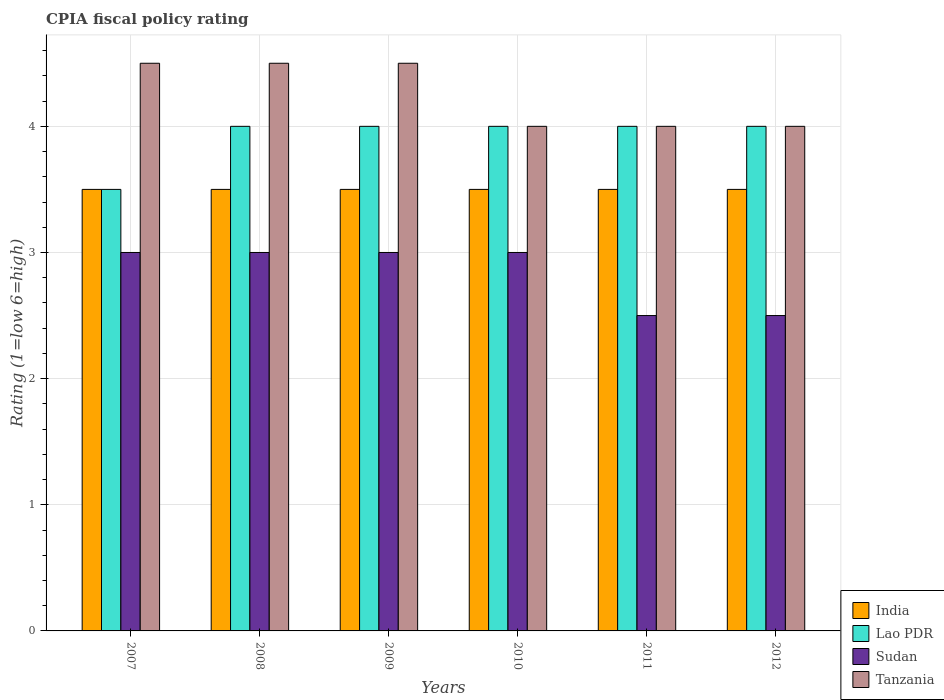Are the number of bars per tick equal to the number of legend labels?
Offer a very short reply. Yes. How many bars are there on the 3rd tick from the left?
Offer a very short reply. 4. How many bars are there on the 5th tick from the right?
Offer a very short reply. 4. In how many cases, is the number of bars for a given year not equal to the number of legend labels?
Offer a terse response. 0. What is the CPIA rating in Sudan in 2009?
Give a very brief answer. 3. Across all years, what is the maximum CPIA rating in India?
Make the answer very short. 3.5. What is the difference between the CPIA rating in India in 2007 and the CPIA rating in Tanzania in 2010?
Provide a short and direct response. -0.5. What is the average CPIA rating in India per year?
Give a very brief answer. 3.5. In the year 2012, what is the difference between the CPIA rating in Sudan and CPIA rating in Tanzania?
Offer a very short reply. -1.5. In how many years, is the CPIA rating in India greater than 3.4?
Make the answer very short. 6. What is the ratio of the CPIA rating in Sudan in 2009 to that in 2010?
Provide a succinct answer. 1. Is the CPIA rating in Sudan in 2007 less than that in 2011?
Give a very brief answer. No. Is the difference between the CPIA rating in Sudan in 2007 and 2011 greater than the difference between the CPIA rating in Tanzania in 2007 and 2011?
Give a very brief answer. No. Is it the case that in every year, the sum of the CPIA rating in Sudan and CPIA rating in Lao PDR is greater than the sum of CPIA rating in Tanzania and CPIA rating in India?
Ensure brevity in your answer.  No. What does the 3rd bar from the left in 2012 represents?
Your answer should be very brief. Sudan. How many years are there in the graph?
Provide a succinct answer. 6. Are the values on the major ticks of Y-axis written in scientific E-notation?
Provide a succinct answer. No. Does the graph contain any zero values?
Ensure brevity in your answer.  No. Where does the legend appear in the graph?
Provide a short and direct response. Bottom right. How many legend labels are there?
Provide a short and direct response. 4. How are the legend labels stacked?
Ensure brevity in your answer.  Vertical. What is the title of the graph?
Give a very brief answer. CPIA fiscal policy rating. Does "Macao" appear as one of the legend labels in the graph?
Provide a succinct answer. No. What is the Rating (1=low 6=high) of India in 2007?
Offer a very short reply. 3.5. What is the Rating (1=low 6=high) in Lao PDR in 2008?
Give a very brief answer. 4. What is the Rating (1=low 6=high) of Tanzania in 2008?
Provide a succinct answer. 4.5. What is the Rating (1=low 6=high) of India in 2009?
Provide a succinct answer. 3.5. What is the Rating (1=low 6=high) in Lao PDR in 2009?
Offer a very short reply. 4. What is the Rating (1=low 6=high) in India in 2010?
Give a very brief answer. 3.5. What is the Rating (1=low 6=high) of Lao PDR in 2010?
Your answer should be compact. 4. What is the Rating (1=low 6=high) of Sudan in 2010?
Offer a very short reply. 3. What is the Rating (1=low 6=high) in Tanzania in 2010?
Your answer should be compact. 4. What is the Rating (1=low 6=high) in Lao PDR in 2011?
Provide a succinct answer. 4. What is the Rating (1=low 6=high) of Lao PDR in 2012?
Offer a very short reply. 4. What is the Rating (1=low 6=high) of Sudan in 2012?
Provide a short and direct response. 2.5. Across all years, what is the maximum Rating (1=low 6=high) of Lao PDR?
Provide a succinct answer. 4. Across all years, what is the maximum Rating (1=low 6=high) in Sudan?
Make the answer very short. 3. Across all years, what is the minimum Rating (1=low 6=high) in Lao PDR?
Provide a short and direct response. 3.5. Across all years, what is the minimum Rating (1=low 6=high) of Sudan?
Give a very brief answer. 2.5. What is the total Rating (1=low 6=high) of India in the graph?
Offer a very short reply. 21. What is the total Rating (1=low 6=high) in Sudan in the graph?
Keep it short and to the point. 17. What is the difference between the Rating (1=low 6=high) in Lao PDR in 2007 and that in 2008?
Provide a succinct answer. -0.5. What is the difference between the Rating (1=low 6=high) in Tanzania in 2007 and that in 2008?
Ensure brevity in your answer.  0. What is the difference between the Rating (1=low 6=high) in Lao PDR in 2007 and that in 2011?
Offer a terse response. -0.5. What is the difference between the Rating (1=low 6=high) of Sudan in 2007 and that in 2011?
Provide a succinct answer. 0.5. What is the difference between the Rating (1=low 6=high) of Tanzania in 2007 and that in 2011?
Offer a very short reply. 0.5. What is the difference between the Rating (1=low 6=high) of India in 2007 and that in 2012?
Your answer should be very brief. 0. What is the difference between the Rating (1=low 6=high) of Lao PDR in 2007 and that in 2012?
Offer a very short reply. -0.5. What is the difference between the Rating (1=low 6=high) in Tanzania in 2007 and that in 2012?
Ensure brevity in your answer.  0.5. What is the difference between the Rating (1=low 6=high) in Sudan in 2008 and that in 2010?
Give a very brief answer. 0. What is the difference between the Rating (1=low 6=high) of India in 2008 and that in 2011?
Make the answer very short. 0. What is the difference between the Rating (1=low 6=high) in Lao PDR in 2008 and that in 2011?
Ensure brevity in your answer.  0. What is the difference between the Rating (1=low 6=high) in Tanzania in 2008 and that in 2012?
Make the answer very short. 0.5. What is the difference between the Rating (1=low 6=high) of Lao PDR in 2009 and that in 2010?
Your answer should be compact. 0. What is the difference between the Rating (1=low 6=high) of Tanzania in 2009 and that in 2010?
Keep it short and to the point. 0.5. What is the difference between the Rating (1=low 6=high) of Sudan in 2009 and that in 2011?
Offer a very short reply. 0.5. What is the difference between the Rating (1=low 6=high) in Lao PDR in 2010 and that in 2011?
Keep it short and to the point. 0. What is the difference between the Rating (1=low 6=high) in Sudan in 2010 and that in 2011?
Give a very brief answer. 0.5. What is the difference between the Rating (1=low 6=high) of India in 2010 and that in 2012?
Your answer should be compact. 0. What is the difference between the Rating (1=low 6=high) of India in 2007 and the Rating (1=low 6=high) of Lao PDR in 2008?
Make the answer very short. -0.5. What is the difference between the Rating (1=low 6=high) of India in 2007 and the Rating (1=low 6=high) of Sudan in 2008?
Provide a short and direct response. 0.5. What is the difference between the Rating (1=low 6=high) in Lao PDR in 2007 and the Rating (1=low 6=high) in Tanzania in 2008?
Ensure brevity in your answer.  -1. What is the difference between the Rating (1=low 6=high) in Sudan in 2007 and the Rating (1=low 6=high) in Tanzania in 2008?
Offer a very short reply. -1.5. What is the difference between the Rating (1=low 6=high) in Lao PDR in 2007 and the Rating (1=low 6=high) in Sudan in 2009?
Provide a short and direct response. 0.5. What is the difference between the Rating (1=low 6=high) in Lao PDR in 2007 and the Rating (1=low 6=high) in Tanzania in 2009?
Offer a very short reply. -1. What is the difference between the Rating (1=low 6=high) in Sudan in 2007 and the Rating (1=low 6=high) in Tanzania in 2009?
Your answer should be very brief. -1.5. What is the difference between the Rating (1=low 6=high) of India in 2007 and the Rating (1=low 6=high) of Lao PDR in 2010?
Offer a terse response. -0.5. What is the difference between the Rating (1=low 6=high) of India in 2007 and the Rating (1=low 6=high) of Sudan in 2010?
Provide a succinct answer. 0.5. What is the difference between the Rating (1=low 6=high) in India in 2007 and the Rating (1=low 6=high) in Tanzania in 2010?
Your response must be concise. -0.5. What is the difference between the Rating (1=low 6=high) of Lao PDR in 2007 and the Rating (1=low 6=high) of Tanzania in 2010?
Keep it short and to the point. -0.5. What is the difference between the Rating (1=low 6=high) of Sudan in 2007 and the Rating (1=low 6=high) of Tanzania in 2010?
Keep it short and to the point. -1. What is the difference between the Rating (1=low 6=high) of Sudan in 2007 and the Rating (1=low 6=high) of Tanzania in 2011?
Provide a short and direct response. -1. What is the difference between the Rating (1=low 6=high) in India in 2007 and the Rating (1=low 6=high) in Lao PDR in 2012?
Offer a terse response. -0.5. What is the difference between the Rating (1=low 6=high) in Lao PDR in 2007 and the Rating (1=low 6=high) in Sudan in 2012?
Keep it short and to the point. 1. What is the difference between the Rating (1=low 6=high) in Lao PDR in 2007 and the Rating (1=low 6=high) in Tanzania in 2012?
Offer a terse response. -0.5. What is the difference between the Rating (1=low 6=high) in Sudan in 2007 and the Rating (1=low 6=high) in Tanzania in 2012?
Make the answer very short. -1. What is the difference between the Rating (1=low 6=high) in India in 2008 and the Rating (1=low 6=high) in Lao PDR in 2009?
Offer a very short reply. -0.5. What is the difference between the Rating (1=low 6=high) in India in 2008 and the Rating (1=low 6=high) in Sudan in 2009?
Your response must be concise. 0.5. What is the difference between the Rating (1=low 6=high) of India in 2008 and the Rating (1=low 6=high) of Tanzania in 2009?
Offer a terse response. -1. What is the difference between the Rating (1=low 6=high) in Sudan in 2008 and the Rating (1=low 6=high) in Tanzania in 2009?
Ensure brevity in your answer.  -1.5. What is the difference between the Rating (1=low 6=high) of India in 2008 and the Rating (1=low 6=high) of Sudan in 2010?
Your answer should be very brief. 0.5. What is the difference between the Rating (1=low 6=high) of India in 2008 and the Rating (1=low 6=high) of Tanzania in 2010?
Your answer should be very brief. -0.5. What is the difference between the Rating (1=low 6=high) in Lao PDR in 2008 and the Rating (1=low 6=high) in Sudan in 2011?
Your answer should be compact. 1.5. What is the difference between the Rating (1=low 6=high) of Lao PDR in 2008 and the Rating (1=low 6=high) of Tanzania in 2011?
Provide a short and direct response. 0. What is the difference between the Rating (1=low 6=high) of India in 2008 and the Rating (1=low 6=high) of Sudan in 2012?
Provide a short and direct response. 1. What is the difference between the Rating (1=low 6=high) in Lao PDR in 2008 and the Rating (1=low 6=high) in Sudan in 2012?
Give a very brief answer. 1.5. What is the difference between the Rating (1=low 6=high) in Lao PDR in 2008 and the Rating (1=low 6=high) in Tanzania in 2012?
Offer a terse response. 0. What is the difference between the Rating (1=low 6=high) of India in 2009 and the Rating (1=low 6=high) of Lao PDR in 2010?
Provide a succinct answer. -0.5. What is the difference between the Rating (1=low 6=high) of India in 2009 and the Rating (1=low 6=high) of Tanzania in 2010?
Make the answer very short. -0.5. What is the difference between the Rating (1=low 6=high) of Lao PDR in 2009 and the Rating (1=low 6=high) of Sudan in 2010?
Provide a short and direct response. 1. What is the difference between the Rating (1=low 6=high) in Lao PDR in 2009 and the Rating (1=low 6=high) in Tanzania in 2010?
Give a very brief answer. 0. What is the difference between the Rating (1=low 6=high) of Sudan in 2009 and the Rating (1=low 6=high) of Tanzania in 2010?
Ensure brevity in your answer.  -1. What is the difference between the Rating (1=low 6=high) in India in 2009 and the Rating (1=low 6=high) in Lao PDR in 2011?
Give a very brief answer. -0.5. What is the difference between the Rating (1=low 6=high) of India in 2009 and the Rating (1=low 6=high) of Sudan in 2011?
Give a very brief answer. 1. What is the difference between the Rating (1=low 6=high) in Lao PDR in 2009 and the Rating (1=low 6=high) in Sudan in 2011?
Make the answer very short. 1.5. What is the difference between the Rating (1=low 6=high) in Lao PDR in 2009 and the Rating (1=low 6=high) in Tanzania in 2011?
Offer a terse response. 0. What is the difference between the Rating (1=low 6=high) in Sudan in 2009 and the Rating (1=low 6=high) in Tanzania in 2011?
Provide a succinct answer. -1. What is the difference between the Rating (1=low 6=high) of India in 2009 and the Rating (1=low 6=high) of Tanzania in 2012?
Provide a succinct answer. -0.5. What is the difference between the Rating (1=low 6=high) of Lao PDR in 2009 and the Rating (1=low 6=high) of Sudan in 2012?
Your answer should be compact. 1.5. What is the difference between the Rating (1=low 6=high) of Lao PDR in 2009 and the Rating (1=low 6=high) of Tanzania in 2012?
Your answer should be compact. 0. What is the difference between the Rating (1=low 6=high) of India in 2010 and the Rating (1=low 6=high) of Sudan in 2011?
Offer a very short reply. 1. What is the difference between the Rating (1=low 6=high) in Lao PDR in 2010 and the Rating (1=low 6=high) in Sudan in 2011?
Your response must be concise. 1.5. What is the difference between the Rating (1=low 6=high) of Lao PDR in 2010 and the Rating (1=low 6=high) of Tanzania in 2011?
Provide a short and direct response. 0. What is the difference between the Rating (1=low 6=high) of Sudan in 2010 and the Rating (1=low 6=high) of Tanzania in 2011?
Offer a very short reply. -1. What is the difference between the Rating (1=low 6=high) of India in 2010 and the Rating (1=low 6=high) of Lao PDR in 2012?
Keep it short and to the point. -0.5. What is the difference between the Rating (1=low 6=high) of India in 2010 and the Rating (1=low 6=high) of Sudan in 2012?
Offer a terse response. 1. What is the difference between the Rating (1=low 6=high) in India in 2010 and the Rating (1=low 6=high) in Tanzania in 2012?
Provide a succinct answer. -0.5. What is the difference between the Rating (1=low 6=high) of Sudan in 2010 and the Rating (1=low 6=high) of Tanzania in 2012?
Offer a terse response. -1. What is the difference between the Rating (1=low 6=high) in India in 2011 and the Rating (1=low 6=high) in Lao PDR in 2012?
Keep it short and to the point. -0.5. What is the difference between the Rating (1=low 6=high) of India in 2011 and the Rating (1=low 6=high) of Sudan in 2012?
Make the answer very short. 1. What is the difference between the Rating (1=low 6=high) of India in 2011 and the Rating (1=low 6=high) of Tanzania in 2012?
Give a very brief answer. -0.5. What is the difference between the Rating (1=low 6=high) of Lao PDR in 2011 and the Rating (1=low 6=high) of Sudan in 2012?
Your answer should be very brief. 1.5. What is the difference between the Rating (1=low 6=high) of Lao PDR in 2011 and the Rating (1=low 6=high) of Tanzania in 2012?
Keep it short and to the point. 0. What is the average Rating (1=low 6=high) of Lao PDR per year?
Provide a short and direct response. 3.92. What is the average Rating (1=low 6=high) of Sudan per year?
Provide a short and direct response. 2.83. What is the average Rating (1=low 6=high) in Tanzania per year?
Your answer should be very brief. 4.25. In the year 2007, what is the difference between the Rating (1=low 6=high) of India and Rating (1=low 6=high) of Lao PDR?
Ensure brevity in your answer.  0. In the year 2007, what is the difference between the Rating (1=low 6=high) of India and Rating (1=low 6=high) of Sudan?
Offer a terse response. 0.5. In the year 2007, what is the difference between the Rating (1=low 6=high) of Lao PDR and Rating (1=low 6=high) of Tanzania?
Keep it short and to the point. -1. In the year 2008, what is the difference between the Rating (1=low 6=high) of Lao PDR and Rating (1=low 6=high) of Sudan?
Your response must be concise. 1. In the year 2008, what is the difference between the Rating (1=low 6=high) of Sudan and Rating (1=low 6=high) of Tanzania?
Your response must be concise. -1.5. In the year 2009, what is the difference between the Rating (1=low 6=high) of India and Rating (1=low 6=high) of Tanzania?
Make the answer very short. -1. In the year 2009, what is the difference between the Rating (1=low 6=high) in Lao PDR and Rating (1=low 6=high) in Sudan?
Ensure brevity in your answer.  1. In the year 2009, what is the difference between the Rating (1=low 6=high) of Lao PDR and Rating (1=low 6=high) of Tanzania?
Your response must be concise. -0.5. In the year 2010, what is the difference between the Rating (1=low 6=high) in India and Rating (1=low 6=high) in Lao PDR?
Your response must be concise. -0.5. In the year 2010, what is the difference between the Rating (1=low 6=high) in India and Rating (1=low 6=high) in Sudan?
Offer a very short reply. 0.5. In the year 2010, what is the difference between the Rating (1=low 6=high) in India and Rating (1=low 6=high) in Tanzania?
Give a very brief answer. -0.5. In the year 2010, what is the difference between the Rating (1=low 6=high) in Lao PDR and Rating (1=low 6=high) in Tanzania?
Give a very brief answer. 0. In the year 2011, what is the difference between the Rating (1=low 6=high) in India and Rating (1=low 6=high) in Lao PDR?
Make the answer very short. -0.5. In the year 2012, what is the difference between the Rating (1=low 6=high) in Lao PDR and Rating (1=low 6=high) in Sudan?
Give a very brief answer. 1.5. In the year 2012, what is the difference between the Rating (1=low 6=high) of Lao PDR and Rating (1=low 6=high) of Tanzania?
Make the answer very short. 0. What is the ratio of the Rating (1=low 6=high) in India in 2007 to that in 2008?
Your answer should be compact. 1. What is the ratio of the Rating (1=low 6=high) in India in 2007 to that in 2009?
Make the answer very short. 1. What is the ratio of the Rating (1=low 6=high) of Sudan in 2007 to that in 2009?
Keep it short and to the point. 1. What is the ratio of the Rating (1=low 6=high) in Sudan in 2007 to that in 2010?
Your response must be concise. 1. What is the ratio of the Rating (1=low 6=high) of Lao PDR in 2007 to that in 2011?
Offer a very short reply. 0.88. What is the ratio of the Rating (1=low 6=high) of Lao PDR in 2007 to that in 2012?
Provide a short and direct response. 0.88. What is the ratio of the Rating (1=low 6=high) of Tanzania in 2007 to that in 2012?
Make the answer very short. 1.12. What is the ratio of the Rating (1=low 6=high) of Lao PDR in 2008 to that in 2009?
Your response must be concise. 1. What is the ratio of the Rating (1=low 6=high) of India in 2008 to that in 2010?
Make the answer very short. 1. What is the ratio of the Rating (1=low 6=high) of Sudan in 2008 to that in 2010?
Offer a very short reply. 1. What is the ratio of the Rating (1=low 6=high) in India in 2008 to that in 2011?
Make the answer very short. 1. What is the ratio of the Rating (1=low 6=high) of Sudan in 2008 to that in 2011?
Your answer should be very brief. 1.2. What is the ratio of the Rating (1=low 6=high) of Tanzania in 2008 to that in 2011?
Provide a succinct answer. 1.12. What is the ratio of the Rating (1=low 6=high) of India in 2008 to that in 2012?
Offer a very short reply. 1. What is the ratio of the Rating (1=low 6=high) of Lao PDR in 2009 to that in 2010?
Ensure brevity in your answer.  1. What is the ratio of the Rating (1=low 6=high) of Tanzania in 2009 to that in 2010?
Offer a terse response. 1.12. What is the ratio of the Rating (1=low 6=high) in India in 2009 to that in 2011?
Ensure brevity in your answer.  1. What is the ratio of the Rating (1=low 6=high) of Lao PDR in 2009 to that in 2011?
Your answer should be very brief. 1. What is the ratio of the Rating (1=low 6=high) of Tanzania in 2009 to that in 2011?
Make the answer very short. 1.12. What is the ratio of the Rating (1=low 6=high) of India in 2009 to that in 2012?
Offer a very short reply. 1. What is the ratio of the Rating (1=low 6=high) in Sudan in 2009 to that in 2012?
Ensure brevity in your answer.  1.2. What is the ratio of the Rating (1=low 6=high) of Tanzania in 2009 to that in 2012?
Keep it short and to the point. 1.12. What is the ratio of the Rating (1=low 6=high) of India in 2010 to that in 2011?
Your answer should be very brief. 1. What is the ratio of the Rating (1=low 6=high) of Lao PDR in 2010 to that in 2011?
Your response must be concise. 1. What is the ratio of the Rating (1=low 6=high) in Sudan in 2010 to that in 2012?
Your response must be concise. 1.2. What is the ratio of the Rating (1=low 6=high) of India in 2011 to that in 2012?
Your response must be concise. 1. What is the ratio of the Rating (1=low 6=high) of Lao PDR in 2011 to that in 2012?
Provide a succinct answer. 1. What is the ratio of the Rating (1=low 6=high) in Sudan in 2011 to that in 2012?
Keep it short and to the point. 1. What is the difference between the highest and the second highest Rating (1=low 6=high) in Lao PDR?
Your response must be concise. 0. What is the difference between the highest and the second highest Rating (1=low 6=high) in Tanzania?
Your answer should be very brief. 0. What is the difference between the highest and the lowest Rating (1=low 6=high) in Sudan?
Ensure brevity in your answer.  0.5. 